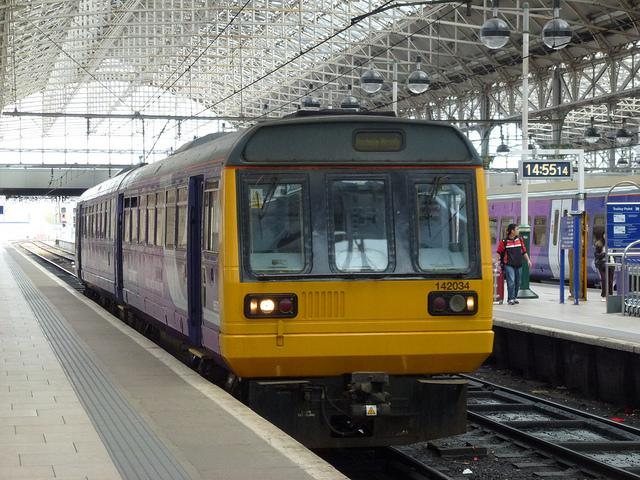What session of the day is shown in the photo? afternoon 